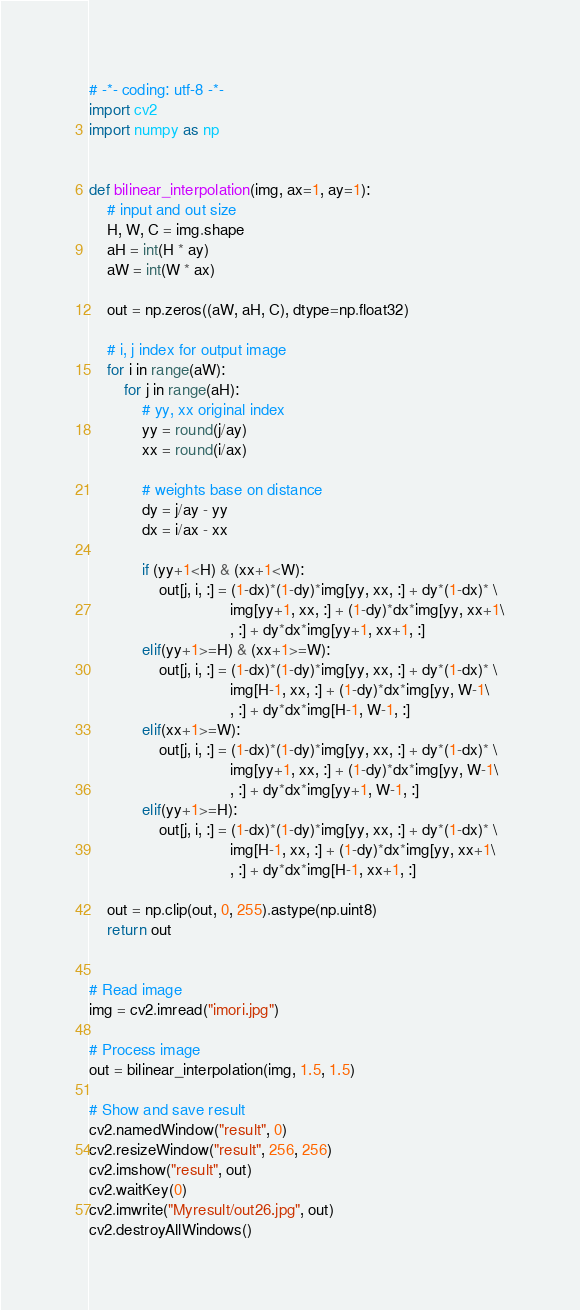<code> <loc_0><loc_0><loc_500><loc_500><_Python_># -*- coding: utf-8 -*-
import cv2
import numpy as np


def bilinear_interpolation(img, ax=1, ay=1):
    # input and out size
    H, W, C = img.shape
    aH = int(H * ay)
    aW = int(W * ax)

    out = np.zeros((aW, aH, C), dtype=np.float32)
    
    # i, j index for output image
    for i in range(aW):
        for j in range(aH):
            # yy, xx original index
            yy = round(j/ay)
            xx = round(i/ax)
            
            # weights base on distance
            dy = j/ay - yy
            dx = i/ax - xx

            if (yy+1<H) & (xx+1<W):
                out[j, i, :] = (1-dx)*(1-dy)*img[yy, xx, :] + dy*(1-dx)* \
                                img[yy+1, xx, :] + (1-dy)*dx*img[yy, xx+1\
                                , :] + dy*dx*img[yy+1, xx+1, :]
            elif(yy+1>=H) & (xx+1>=W):
                out[j, i, :] = (1-dx)*(1-dy)*img[yy, xx, :] + dy*(1-dx)* \
                                img[H-1, xx, :] + (1-dy)*dx*img[yy, W-1\
                                , :] + dy*dx*img[H-1, W-1, :]
            elif(xx+1>=W):
                out[j, i, :] = (1-dx)*(1-dy)*img[yy, xx, :] + dy*(1-dx)* \
                                img[yy+1, xx, :] + (1-dy)*dx*img[yy, W-1\
                                , :] + dy*dx*img[yy+1, W-1, :]
            elif(yy+1>=H):
                out[j, i, :] = (1-dx)*(1-dy)*img[yy, xx, :] + dy*(1-dx)* \
                                img[H-1, xx, :] + (1-dy)*dx*img[yy, xx+1\
                                , :] + dy*dx*img[H-1, xx+1, :]   
            
    out = np.clip(out, 0, 255).astype(np.uint8)
    return out


# Read image
img = cv2.imread("imori.jpg")

# Process image
out = bilinear_interpolation(img, 1.5, 1.5)

# Show and save result
cv2.namedWindow("result", 0)
cv2.resizeWindow("result", 256, 256)
cv2.imshow("result", out)
cv2.waitKey(0)
cv2.imwrite("Myresult/out26.jpg", out)
cv2.destroyAllWindows()
</code> 